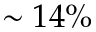Convert formula to latex. <formula><loc_0><loc_0><loc_500><loc_500>\sim 1 4 \%</formula> 